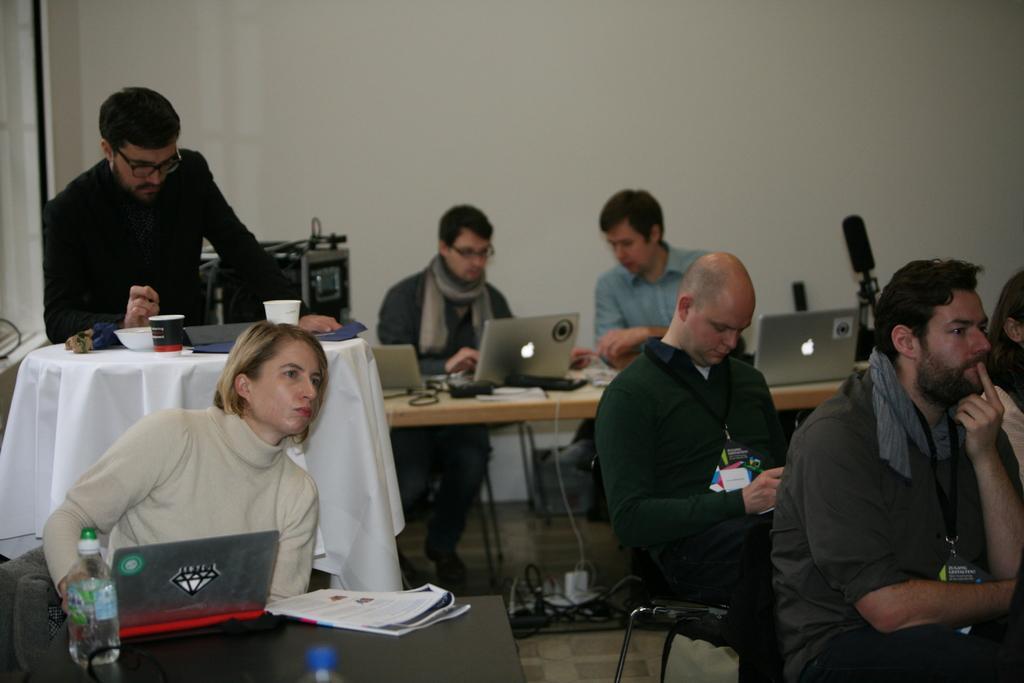Please provide a concise description of this image. In this image, we can see a group of people. Few are sitting on the chairs. On the left side of the image, a person is standing behind the table. This table is covered with white cloth. Few objects are placed on it. In this image, we can see laptops, bottles, tables and few things. At the bottom, there is a floor. Background we can see the wall. 